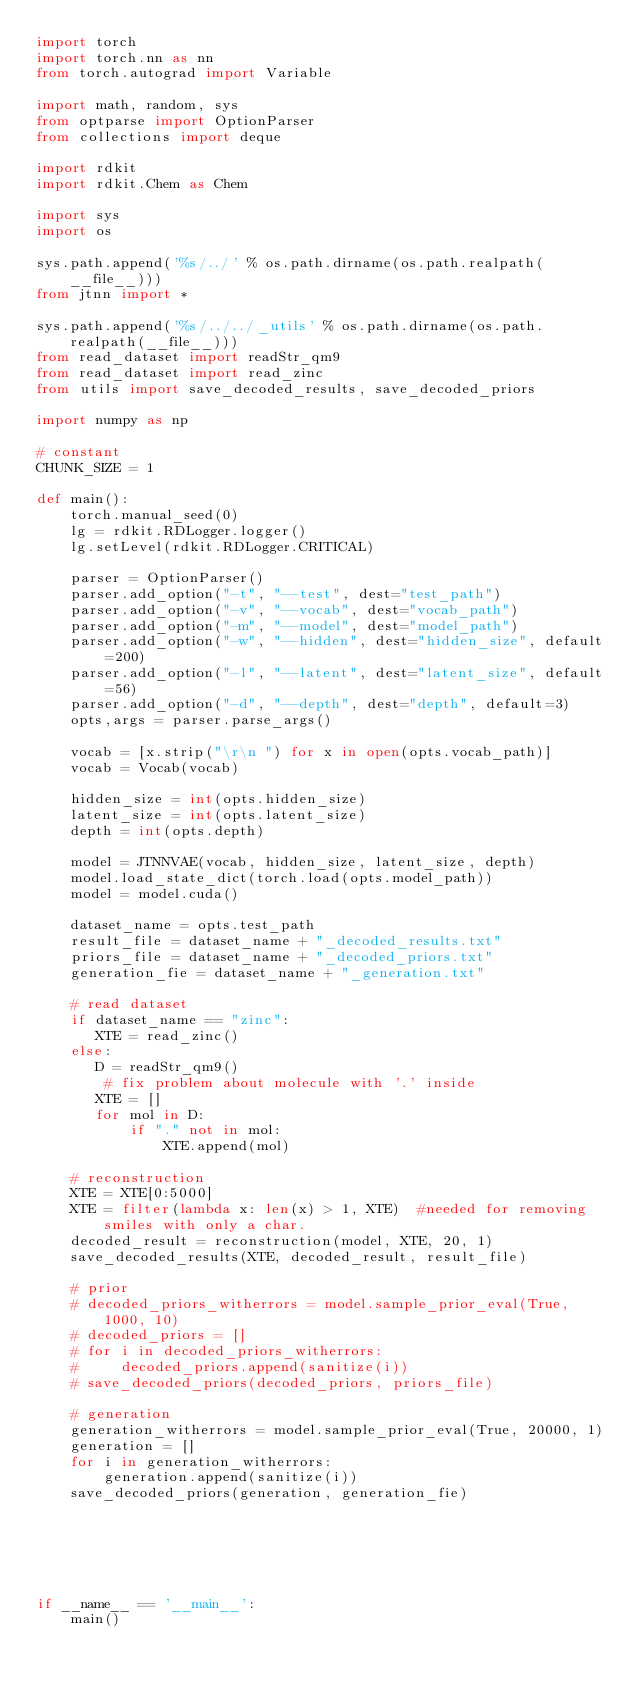<code> <loc_0><loc_0><loc_500><loc_500><_Python_>import torch
import torch.nn as nn
from torch.autograd import Variable

import math, random, sys
from optparse import OptionParser
from collections import deque

import rdkit
import rdkit.Chem as Chem

import sys
import os

sys.path.append('%s/../' % os.path.dirname(os.path.realpath(__file__)))
from jtnn import *

sys.path.append('%s/../../_utils' % os.path.dirname(os.path.realpath(__file__)))
from read_dataset import readStr_qm9
from read_dataset import read_zinc
from utils import save_decoded_results, save_decoded_priors

import numpy as np

# constant
CHUNK_SIZE = 1

def main():
    torch.manual_seed(0)
    lg = rdkit.RDLogger.logger()
    lg.setLevel(rdkit.RDLogger.CRITICAL)

    parser = OptionParser()
    parser.add_option("-t", "--test", dest="test_path")
    parser.add_option("-v", "--vocab", dest="vocab_path")
    parser.add_option("-m", "--model", dest="model_path")
    parser.add_option("-w", "--hidden", dest="hidden_size", default=200)
    parser.add_option("-l", "--latent", dest="latent_size", default=56)
    parser.add_option("-d", "--depth", dest="depth", default=3)
    opts,args = parser.parse_args()

    vocab = [x.strip("\r\n ") for x in open(opts.vocab_path)]
    vocab = Vocab(vocab)

    hidden_size = int(opts.hidden_size)
    latent_size = int(opts.latent_size)
    depth = int(opts.depth)

    model = JTNNVAE(vocab, hidden_size, latent_size, depth)
    model.load_state_dict(torch.load(opts.model_path))
    model = model.cuda()

    dataset_name = opts.test_path
    result_file = dataset_name + "_decoded_results.txt"
    priors_file = dataset_name + "_decoded_priors.txt"
    generation_fie = dataset_name + "_generation.txt"

    # read dataset
    if dataset_name == "zinc":
       XTE = read_zinc()
    else:
       D = readStr_qm9()
        # fix problem about molecule with '.' inside
       XTE = []
       for mol in D:
           if "." not in mol:
               XTE.append(mol)

    # reconstruction
    XTE = XTE[0:5000]
    XTE = filter(lambda x: len(x) > 1, XTE)  #needed for removing smiles with only a char.
    decoded_result = reconstruction(model, XTE, 20, 1)
    save_decoded_results(XTE, decoded_result, result_file)

    # prior
    # decoded_priors_witherrors = model.sample_prior_eval(True, 1000, 10)
    # decoded_priors = []
    # for i in decoded_priors_witherrors:
    #     decoded_priors.append(sanitize(i))
    # save_decoded_priors(decoded_priors, priors_file)

    # generation
    generation_witherrors = model.sample_prior_eval(True, 20000, 1)
    generation = []
    for i in generation_witherrors:
        generation.append(sanitize(i))
    save_decoded_priors(generation, generation_fie)






if __name__ == '__main__':
    main()
</code> 